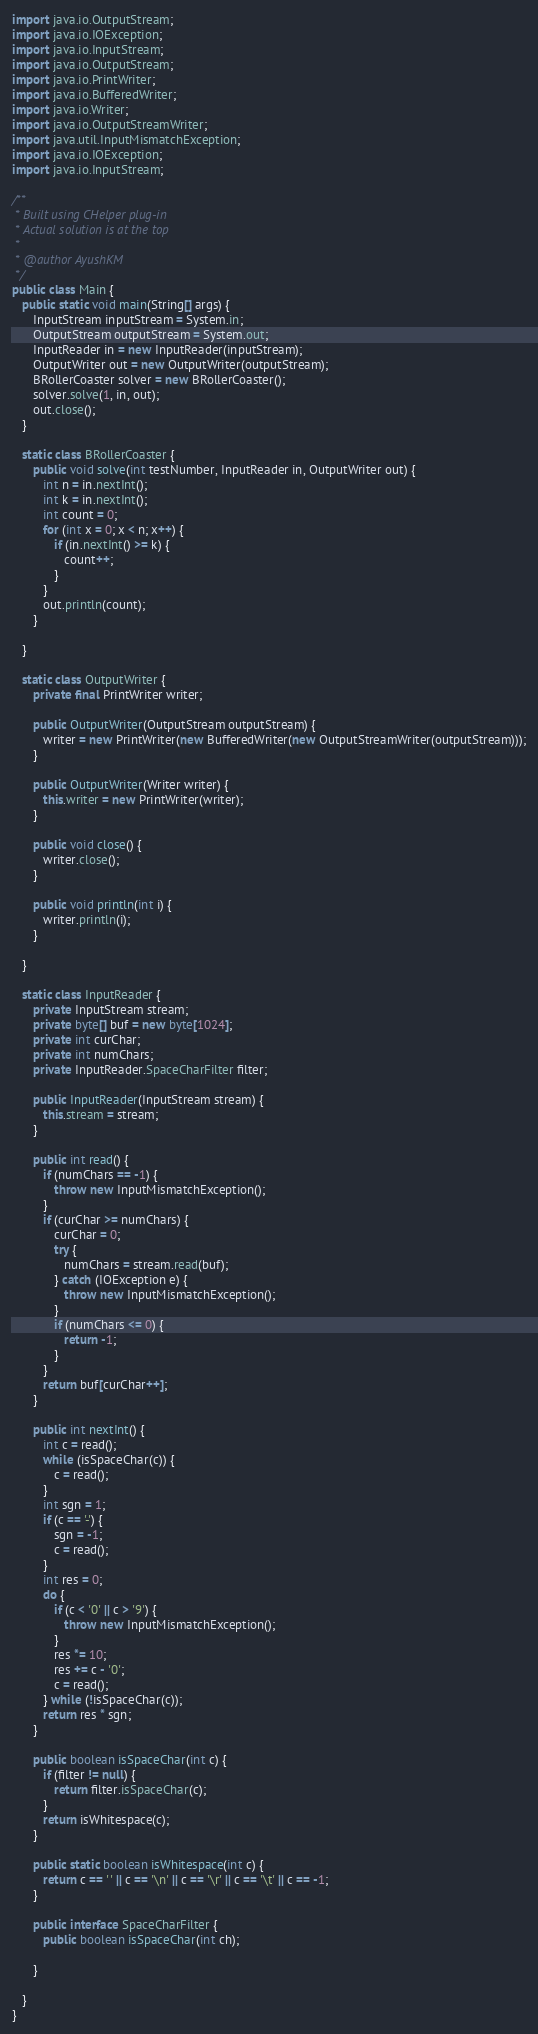Convert code to text. <code><loc_0><loc_0><loc_500><loc_500><_Java_>import java.io.OutputStream;
import java.io.IOException;
import java.io.InputStream;
import java.io.OutputStream;
import java.io.PrintWriter;
import java.io.BufferedWriter;
import java.io.Writer;
import java.io.OutputStreamWriter;
import java.util.InputMismatchException;
import java.io.IOException;
import java.io.InputStream;

/**
 * Built using CHelper plug-in
 * Actual solution is at the top
 *
 * @author AyushKM
 */
public class Main {
   public static void main(String[] args) {
      InputStream inputStream = System.in;
      OutputStream outputStream = System.out;
      InputReader in = new InputReader(inputStream);
      OutputWriter out = new OutputWriter(outputStream);
      BRollerCoaster solver = new BRollerCoaster();
      solver.solve(1, in, out);
      out.close();
   }

   static class BRollerCoaster {
      public void solve(int testNumber, InputReader in, OutputWriter out) {
         int n = in.nextInt();
         int k = in.nextInt();
         int count = 0;
         for (int x = 0; x < n; x++) {
            if (in.nextInt() >= k) {
               count++;
            }
         }
         out.println(count);
      }

   }

   static class OutputWriter {
      private final PrintWriter writer;

      public OutputWriter(OutputStream outputStream) {
         writer = new PrintWriter(new BufferedWriter(new OutputStreamWriter(outputStream)));
      }

      public OutputWriter(Writer writer) {
         this.writer = new PrintWriter(writer);
      }

      public void close() {
         writer.close();
      }

      public void println(int i) {
         writer.println(i);
      }

   }

   static class InputReader {
      private InputStream stream;
      private byte[] buf = new byte[1024];
      private int curChar;
      private int numChars;
      private InputReader.SpaceCharFilter filter;

      public InputReader(InputStream stream) {
         this.stream = stream;
      }

      public int read() {
         if (numChars == -1) {
            throw new InputMismatchException();
         }
         if (curChar >= numChars) {
            curChar = 0;
            try {
               numChars = stream.read(buf);
            } catch (IOException e) {
               throw new InputMismatchException();
            }
            if (numChars <= 0) {
               return -1;
            }
         }
         return buf[curChar++];
      }

      public int nextInt() {
         int c = read();
         while (isSpaceChar(c)) {
            c = read();
         }
         int sgn = 1;
         if (c == '-') {
            sgn = -1;
            c = read();
         }
         int res = 0;
         do {
            if (c < '0' || c > '9') {
               throw new InputMismatchException();
            }
            res *= 10;
            res += c - '0';
            c = read();
         } while (!isSpaceChar(c));
         return res * sgn;
      }

      public boolean isSpaceChar(int c) {
         if (filter != null) {
            return filter.isSpaceChar(c);
         }
         return isWhitespace(c);
      }

      public static boolean isWhitespace(int c) {
         return c == ' ' || c == '\n' || c == '\r' || c == '\t' || c == -1;
      }

      public interface SpaceCharFilter {
         public boolean isSpaceChar(int ch);

      }

   }
}

</code> 